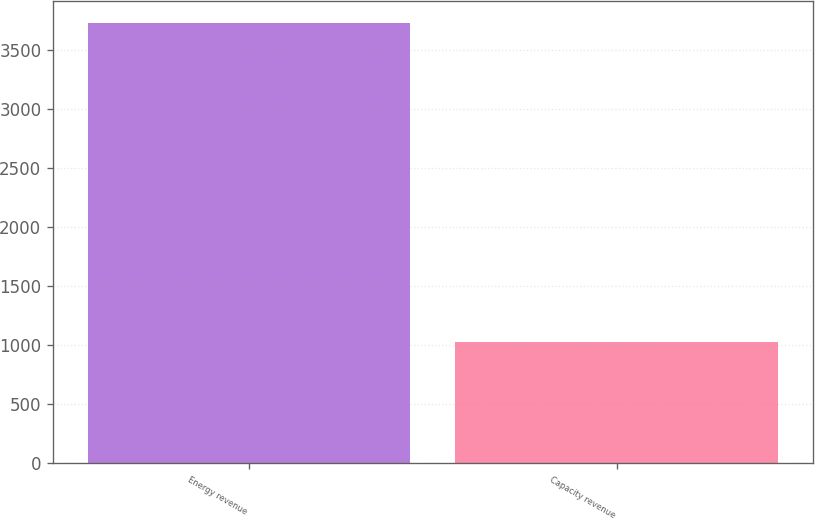Convert chart to OTSL. <chart><loc_0><loc_0><loc_500><loc_500><bar_chart><fcel>Energy revenue<fcel>Capacity revenue<nl><fcel>3726<fcel>1023<nl></chart> 